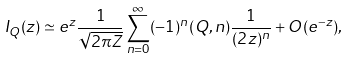<formula> <loc_0><loc_0><loc_500><loc_500>I _ { Q } ( z ) \simeq e ^ { z } \frac { 1 } { \sqrt { 2 \pi Z } } \sum _ { n = 0 } ^ { \infty } ( - 1 ) ^ { n } ( Q , n ) \frac { 1 } { ( 2 z ) ^ { n } } + O ( e ^ { - z } ) ,</formula> 